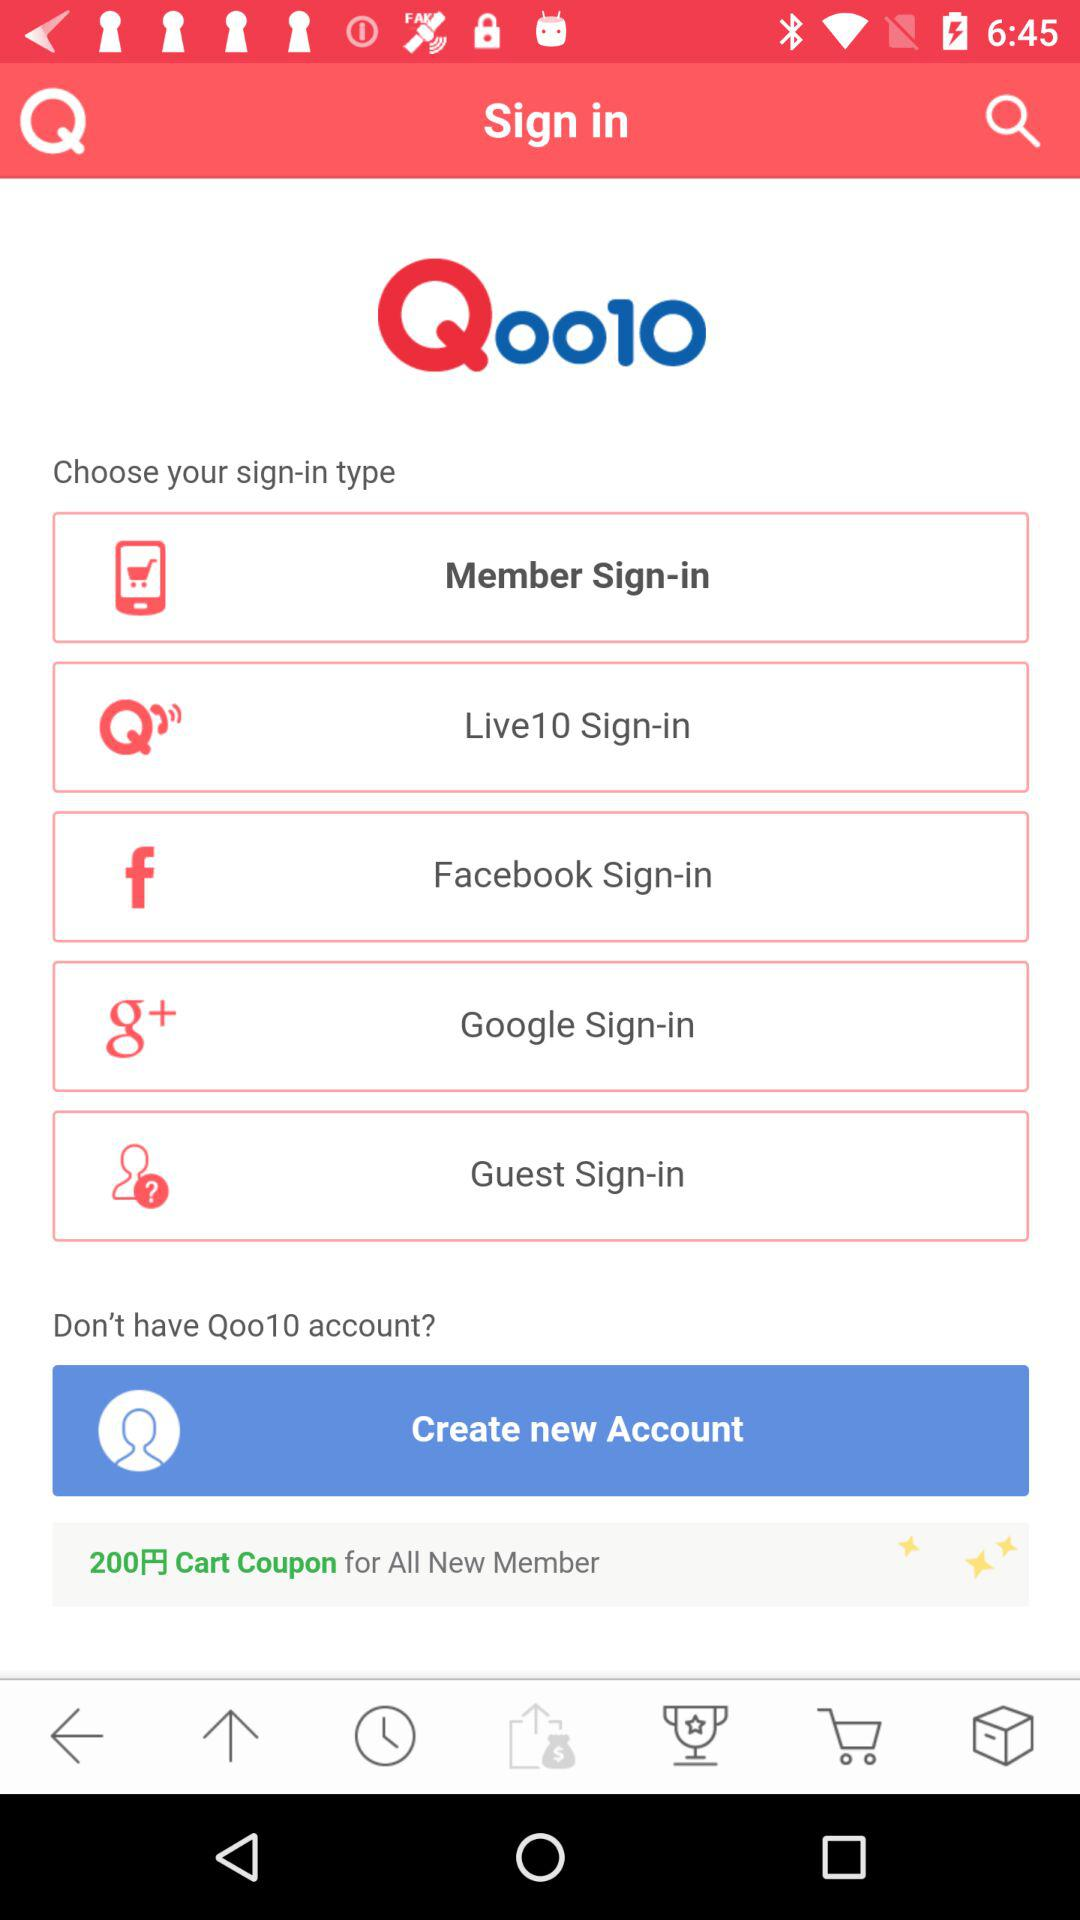What is the application name? The application name is "Qoo10". 